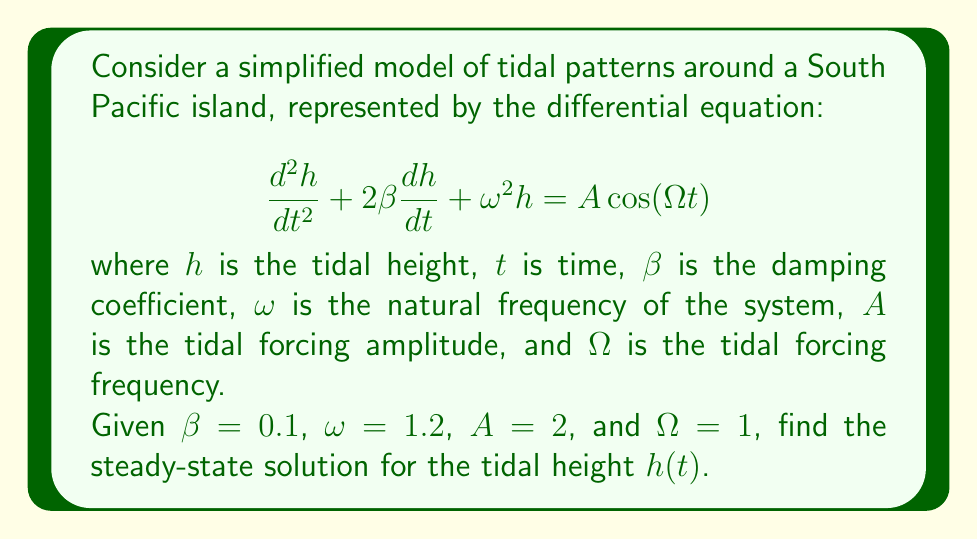Give your solution to this math problem. To find the steady-state solution, we follow these steps:

1) The general form of the steady-state solution for a forced oscillation is:

   $$h(t) = C\cos(\Omega t - \phi)$$

   where $C$ is the amplitude and $\phi$ is the phase shift.

2) We need to find $C$ and $\phi$. For this, we use the following formulas:

   $$C = \frac{A}{\sqrt{(\omega^2 - \Omega^2)^2 + 4\beta^2\Omega^2}}$$

   $$\tan\phi = \frac{2\beta\Omega}{\omega^2 - \Omega^2}$$

3) Let's calculate $C$ first:
   
   $$C = \frac{2}{\sqrt{(1.2^2 - 1^2)^2 + 4(0.1^2)(1^2)}}$$
   $$= \frac{2}{\sqrt{(0.44)^2 + 0.04}}$$
   $$= \frac{2}{\sqrt{0.1936 + 0.04}}$$
   $$= \frac{2}{\sqrt{0.2336}}$$
   $$= \frac{2}{0.4833}$$
   $$\approx 4.1382$$

4) Now, let's calculate $\phi$:
   
   $$\tan\phi = \frac{2(0.1)(1)}{1.2^2 - 1^2} = \frac{0.2}{0.44} \approx 0.4545$$
   
   $$\phi = \arctan(0.4545) \approx 0.4276 \text{ radians}$$

5) Therefore, the steady-state solution is:

   $$h(t) \approx 4.1382\cos(t - 0.4276)$$
Answer: $h(t) \approx 4.1382\cos(t - 0.4276)$ 